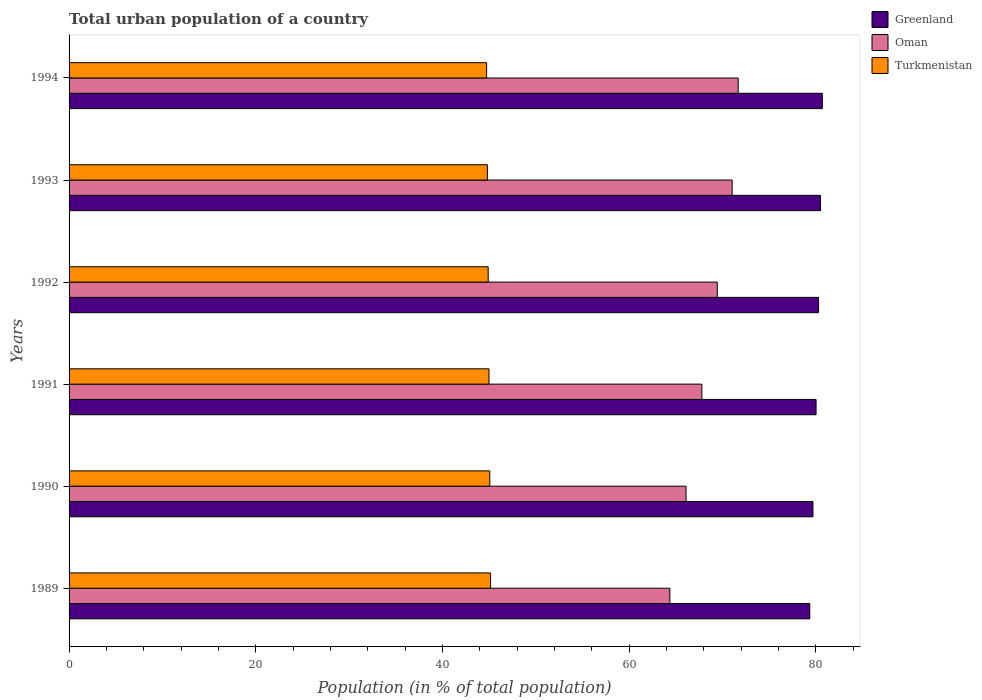How many different coloured bars are there?
Provide a short and direct response. 3. Are the number of bars per tick equal to the number of legend labels?
Provide a short and direct response. Yes. Are the number of bars on each tick of the Y-axis equal?
Make the answer very short. Yes. How many bars are there on the 3rd tick from the top?
Your answer should be very brief. 3. What is the label of the 5th group of bars from the top?
Keep it short and to the point. 1990. In how many cases, is the number of bars for a given year not equal to the number of legend labels?
Keep it short and to the point. 0. What is the urban population in Greenland in 1989?
Make the answer very short. 79.36. Across all years, what is the maximum urban population in Oman?
Keep it short and to the point. 71.69. Across all years, what is the minimum urban population in Oman?
Give a very brief answer. 64.37. What is the total urban population in Oman in the graph?
Give a very brief answer. 410.44. What is the difference between the urban population in Oman in 1990 and that in 1991?
Your answer should be very brief. -1.69. What is the difference between the urban population in Greenland in 1992 and the urban population in Oman in 1991?
Provide a succinct answer. 12.5. What is the average urban population in Greenland per year?
Your response must be concise. 80.1. In the year 1990, what is the difference between the urban population in Oman and urban population in Turkmenistan?
Your response must be concise. 21.03. In how many years, is the urban population in Greenland greater than 68 %?
Provide a succinct answer. 6. What is the ratio of the urban population in Oman in 1989 to that in 1993?
Offer a terse response. 0.91. Is the urban population in Oman in 1989 less than that in 1991?
Provide a succinct answer. Yes. Is the difference between the urban population in Oman in 1993 and 1994 greater than the difference between the urban population in Turkmenistan in 1993 and 1994?
Offer a terse response. No. What is the difference between the highest and the second highest urban population in Turkmenistan?
Your response must be concise. 0.08. What is the difference between the highest and the lowest urban population in Greenland?
Your answer should be compact. 1.34. What does the 3rd bar from the top in 1992 represents?
Ensure brevity in your answer.  Greenland. What does the 1st bar from the bottom in 1992 represents?
Your response must be concise. Greenland. Are all the bars in the graph horizontal?
Offer a terse response. Yes. What is the difference between two consecutive major ticks on the X-axis?
Offer a very short reply. 20. Are the values on the major ticks of X-axis written in scientific E-notation?
Offer a very short reply. No. Does the graph contain any zero values?
Your answer should be compact. No. Where does the legend appear in the graph?
Your response must be concise. Top right. How many legend labels are there?
Provide a short and direct response. 3. What is the title of the graph?
Provide a short and direct response. Total urban population of a country. What is the label or title of the X-axis?
Your response must be concise. Population (in % of total population). What is the label or title of the Y-axis?
Your response must be concise. Years. What is the Population (in % of total population) of Greenland in 1989?
Your response must be concise. 79.36. What is the Population (in % of total population) of Oman in 1989?
Keep it short and to the point. 64.37. What is the Population (in % of total population) of Turkmenistan in 1989?
Offer a very short reply. 45.16. What is the Population (in % of total population) in Greenland in 1990?
Your response must be concise. 79.7. What is the Population (in % of total population) of Oman in 1990?
Offer a terse response. 66.1. What is the Population (in % of total population) in Turkmenistan in 1990?
Make the answer very short. 45.08. What is the Population (in % of total population) in Greenland in 1991?
Make the answer very short. 80.03. What is the Population (in % of total population) in Oman in 1991?
Ensure brevity in your answer.  67.8. What is the Population (in % of total population) of Turkmenistan in 1991?
Give a very brief answer. 44.99. What is the Population (in % of total population) in Greenland in 1992?
Provide a short and direct response. 80.3. What is the Population (in % of total population) of Oman in 1992?
Give a very brief answer. 69.45. What is the Population (in % of total population) of Turkmenistan in 1992?
Offer a very short reply. 44.9. What is the Population (in % of total population) of Greenland in 1993?
Your answer should be compact. 80.5. What is the Population (in % of total population) in Oman in 1993?
Provide a succinct answer. 71.04. What is the Population (in % of total population) of Turkmenistan in 1993?
Give a very brief answer. 44.82. What is the Population (in % of total population) in Greenland in 1994?
Offer a terse response. 80.7. What is the Population (in % of total population) in Oman in 1994?
Your answer should be very brief. 71.69. What is the Population (in % of total population) in Turkmenistan in 1994?
Make the answer very short. 44.73. Across all years, what is the maximum Population (in % of total population) in Greenland?
Give a very brief answer. 80.7. Across all years, what is the maximum Population (in % of total population) of Oman?
Make the answer very short. 71.69. Across all years, what is the maximum Population (in % of total population) of Turkmenistan?
Make the answer very short. 45.16. Across all years, what is the minimum Population (in % of total population) in Greenland?
Make the answer very short. 79.36. Across all years, what is the minimum Population (in % of total population) of Oman?
Your response must be concise. 64.37. Across all years, what is the minimum Population (in % of total population) in Turkmenistan?
Your response must be concise. 44.73. What is the total Population (in % of total population) of Greenland in the graph?
Ensure brevity in your answer.  480.6. What is the total Population (in % of total population) of Oman in the graph?
Your answer should be very brief. 410.44. What is the total Population (in % of total population) of Turkmenistan in the graph?
Your answer should be compact. 269.68. What is the difference between the Population (in % of total population) in Greenland in 1989 and that in 1990?
Your response must be concise. -0.34. What is the difference between the Population (in % of total population) of Oman in 1989 and that in 1990?
Your answer should be compact. -1.74. What is the difference between the Population (in % of total population) in Turkmenistan in 1989 and that in 1990?
Provide a succinct answer. 0.09. What is the difference between the Population (in % of total population) in Greenland in 1989 and that in 1991?
Your response must be concise. -0.67. What is the difference between the Population (in % of total population) in Oman in 1989 and that in 1991?
Offer a very short reply. -3.43. What is the difference between the Population (in % of total population) of Turkmenistan in 1989 and that in 1991?
Offer a very short reply. 0.17. What is the difference between the Population (in % of total population) of Greenland in 1989 and that in 1992?
Offer a terse response. -0.94. What is the difference between the Population (in % of total population) in Oman in 1989 and that in 1992?
Your answer should be compact. -5.08. What is the difference between the Population (in % of total population) in Turkmenistan in 1989 and that in 1992?
Make the answer very short. 0.26. What is the difference between the Population (in % of total population) in Greenland in 1989 and that in 1993?
Make the answer very short. -1.14. What is the difference between the Population (in % of total population) in Oman in 1989 and that in 1993?
Keep it short and to the point. -6.68. What is the difference between the Population (in % of total population) in Turkmenistan in 1989 and that in 1993?
Make the answer very short. 0.34. What is the difference between the Population (in % of total population) of Greenland in 1989 and that in 1994?
Your answer should be very brief. -1.34. What is the difference between the Population (in % of total population) in Oman in 1989 and that in 1994?
Provide a succinct answer. -7.32. What is the difference between the Population (in % of total population) in Turkmenistan in 1989 and that in 1994?
Ensure brevity in your answer.  0.43. What is the difference between the Population (in % of total population) of Greenland in 1990 and that in 1991?
Your answer should be very brief. -0.34. What is the difference between the Population (in % of total population) of Oman in 1990 and that in 1991?
Your answer should be very brief. -1.69. What is the difference between the Population (in % of total population) in Turkmenistan in 1990 and that in 1991?
Your response must be concise. 0.09. What is the difference between the Population (in % of total population) in Greenland in 1990 and that in 1992?
Your answer should be very brief. -0.6. What is the difference between the Population (in % of total population) in Oman in 1990 and that in 1992?
Your answer should be compact. -3.35. What is the difference between the Population (in % of total population) in Turkmenistan in 1990 and that in 1992?
Provide a succinct answer. 0.17. What is the difference between the Population (in % of total population) in Greenland in 1990 and that in 1993?
Your response must be concise. -0.81. What is the difference between the Population (in % of total population) of Oman in 1990 and that in 1993?
Provide a short and direct response. -4.94. What is the difference between the Population (in % of total population) in Turkmenistan in 1990 and that in 1993?
Provide a succinct answer. 0.26. What is the difference between the Population (in % of total population) of Greenland in 1990 and that in 1994?
Your answer should be compact. -1. What is the difference between the Population (in % of total population) of Oman in 1990 and that in 1994?
Keep it short and to the point. -5.59. What is the difference between the Population (in % of total population) in Turkmenistan in 1990 and that in 1994?
Offer a terse response. 0.34. What is the difference between the Population (in % of total population) in Greenland in 1991 and that in 1992?
Provide a succinct answer. -0.27. What is the difference between the Population (in % of total population) in Oman in 1991 and that in 1992?
Ensure brevity in your answer.  -1.65. What is the difference between the Population (in % of total population) of Turkmenistan in 1991 and that in 1992?
Provide a short and direct response. 0.09. What is the difference between the Population (in % of total population) of Greenland in 1991 and that in 1993?
Your answer should be very brief. -0.47. What is the difference between the Population (in % of total population) of Oman in 1991 and that in 1993?
Your answer should be compact. -3.25. What is the difference between the Population (in % of total population) of Turkmenistan in 1991 and that in 1993?
Offer a very short reply. 0.17. What is the difference between the Population (in % of total population) in Greenland in 1991 and that in 1994?
Give a very brief answer. -0.67. What is the difference between the Population (in % of total population) of Oman in 1991 and that in 1994?
Make the answer very short. -3.89. What is the difference between the Population (in % of total population) of Turkmenistan in 1991 and that in 1994?
Give a very brief answer. 0.26. What is the difference between the Population (in % of total population) of Greenland in 1992 and that in 1993?
Your response must be concise. -0.2. What is the difference between the Population (in % of total population) in Oman in 1992 and that in 1993?
Provide a short and direct response. -1.6. What is the difference between the Population (in % of total population) of Turkmenistan in 1992 and that in 1993?
Give a very brief answer. 0.09. What is the difference between the Population (in % of total population) in Greenland in 1992 and that in 1994?
Keep it short and to the point. -0.4. What is the difference between the Population (in % of total population) of Oman in 1992 and that in 1994?
Your response must be concise. -2.24. What is the difference between the Population (in % of total population) in Turkmenistan in 1992 and that in 1994?
Make the answer very short. 0.17. What is the difference between the Population (in % of total population) of Oman in 1993 and that in 1994?
Your answer should be very brief. -0.64. What is the difference between the Population (in % of total population) of Turkmenistan in 1993 and that in 1994?
Provide a succinct answer. 0.09. What is the difference between the Population (in % of total population) of Greenland in 1989 and the Population (in % of total population) of Oman in 1990?
Offer a very short reply. 13.26. What is the difference between the Population (in % of total population) in Greenland in 1989 and the Population (in % of total population) in Turkmenistan in 1990?
Ensure brevity in your answer.  34.28. What is the difference between the Population (in % of total population) of Oman in 1989 and the Population (in % of total population) of Turkmenistan in 1990?
Your response must be concise. 19.29. What is the difference between the Population (in % of total population) of Greenland in 1989 and the Population (in % of total population) of Oman in 1991?
Give a very brief answer. 11.56. What is the difference between the Population (in % of total population) of Greenland in 1989 and the Population (in % of total population) of Turkmenistan in 1991?
Make the answer very short. 34.37. What is the difference between the Population (in % of total population) in Oman in 1989 and the Population (in % of total population) in Turkmenistan in 1991?
Your answer should be very brief. 19.38. What is the difference between the Population (in % of total population) of Greenland in 1989 and the Population (in % of total population) of Oman in 1992?
Provide a short and direct response. 9.91. What is the difference between the Population (in % of total population) of Greenland in 1989 and the Population (in % of total population) of Turkmenistan in 1992?
Your answer should be compact. 34.45. What is the difference between the Population (in % of total population) in Oman in 1989 and the Population (in % of total population) in Turkmenistan in 1992?
Give a very brief answer. 19.46. What is the difference between the Population (in % of total population) of Greenland in 1989 and the Population (in % of total population) of Oman in 1993?
Provide a short and direct response. 8.31. What is the difference between the Population (in % of total population) of Greenland in 1989 and the Population (in % of total population) of Turkmenistan in 1993?
Your answer should be very brief. 34.54. What is the difference between the Population (in % of total population) of Oman in 1989 and the Population (in % of total population) of Turkmenistan in 1993?
Offer a terse response. 19.55. What is the difference between the Population (in % of total population) of Greenland in 1989 and the Population (in % of total population) of Oman in 1994?
Provide a succinct answer. 7.67. What is the difference between the Population (in % of total population) in Greenland in 1989 and the Population (in % of total population) in Turkmenistan in 1994?
Your answer should be very brief. 34.62. What is the difference between the Population (in % of total population) in Oman in 1989 and the Population (in % of total population) in Turkmenistan in 1994?
Offer a very short reply. 19.63. What is the difference between the Population (in % of total population) of Greenland in 1990 and the Population (in % of total population) of Oman in 1991?
Give a very brief answer. 11.9. What is the difference between the Population (in % of total population) of Greenland in 1990 and the Population (in % of total population) of Turkmenistan in 1991?
Give a very brief answer. 34.71. What is the difference between the Population (in % of total population) in Oman in 1990 and the Population (in % of total population) in Turkmenistan in 1991?
Make the answer very short. 21.11. What is the difference between the Population (in % of total population) of Greenland in 1990 and the Population (in % of total population) of Oman in 1992?
Give a very brief answer. 10.25. What is the difference between the Population (in % of total population) in Greenland in 1990 and the Population (in % of total population) in Turkmenistan in 1992?
Provide a short and direct response. 34.79. What is the difference between the Population (in % of total population) in Oman in 1990 and the Population (in % of total population) in Turkmenistan in 1992?
Provide a short and direct response. 21.2. What is the difference between the Population (in % of total population) of Greenland in 1990 and the Population (in % of total population) of Oman in 1993?
Provide a short and direct response. 8.65. What is the difference between the Population (in % of total population) in Greenland in 1990 and the Population (in % of total population) in Turkmenistan in 1993?
Provide a short and direct response. 34.88. What is the difference between the Population (in % of total population) in Oman in 1990 and the Population (in % of total population) in Turkmenistan in 1993?
Your response must be concise. 21.28. What is the difference between the Population (in % of total population) in Greenland in 1990 and the Population (in % of total population) in Oman in 1994?
Give a very brief answer. 8.01. What is the difference between the Population (in % of total population) in Greenland in 1990 and the Population (in % of total population) in Turkmenistan in 1994?
Offer a terse response. 34.96. What is the difference between the Population (in % of total population) of Oman in 1990 and the Population (in % of total population) of Turkmenistan in 1994?
Ensure brevity in your answer.  21.37. What is the difference between the Population (in % of total population) of Greenland in 1991 and the Population (in % of total population) of Oman in 1992?
Your response must be concise. 10.59. What is the difference between the Population (in % of total population) in Greenland in 1991 and the Population (in % of total population) in Turkmenistan in 1992?
Your answer should be very brief. 35.13. What is the difference between the Population (in % of total population) in Oman in 1991 and the Population (in % of total population) in Turkmenistan in 1992?
Make the answer very short. 22.89. What is the difference between the Population (in % of total population) of Greenland in 1991 and the Population (in % of total population) of Oman in 1993?
Your answer should be very brief. 8.99. What is the difference between the Population (in % of total population) of Greenland in 1991 and the Population (in % of total population) of Turkmenistan in 1993?
Your answer should be compact. 35.21. What is the difference between the Population (in % of total population) of Oman in 1991 and the Population (in % of total population) of Turkmenistan in 1993?
Ensure brevity in your answer.  22.98. What is the difference between the Population (in % of total population) in Greenland in 1991 and the Population (in % of total population) in Oman in 1994?
Make the answer very short. 8.35. What is the difference between the Population (in % of total population) of Greenland in 1991 and the Population (in % of total population) of Turkmenistan in 1994?
Ensure brevity in your answer.  35.3. What is the difference between the Population (in % of total population) in Oman in 1991 and the Population (in % of total population) in Turkmenistan in 1994?
Provide a short and direct response. 23.06. What is the difference between the Population (in % of total population) of Greenland in 1992 and the Population (in % of total population) of Oman in 1993?
Provide a succinct answer. 9.26. What is the difference between the Population (in % of total population) in Greenland in 1992 and the Population (in % of total population) in Turkmenistan in 1993?
Offer a very short reply. 35.48. What is the difference between the Population (in % of total population) of Oman in 1992 and the Population (in % of total population) of Turkmenistan in 1993?
Give a very brief answer. 24.63. What is the difference between the Population (in % of total population) in Greenland in 1992 and the Population (in % of total population) in Oman in 1994?
Offer a very short reply. 8.61. What is the difference between the Population (in % of total population) in Greenland in 1992 and the Population (in % of total population) in Turkmenistan in 1994?
Your answer should be compact. 35.57. What is the difference between the Population (in % of total population) in Oman in 1992 and the Population (in % of total population) in Turkmenistan in 1994?
Make the answer very short. 24.71. What is the difference between the Population (in % of total population) of Greenland in 1993 and the Population (in % of total population) of Oman in 1994?
Give a very brief answer. 8.81. What is the difference between the Population (in % of total population) in Greenland in 1993 and the Population (in % of total population) in Turkmenistan in 1994?
Provide a succinct answer. 35.77. What is the difference between the Population (in % of total population) of Oman in 1993 and the Population (in % of total population) of Turkmenistan in 1994?
Provide a succinct answer. 26.31. What is the average Population (in % of total population) in Greenland per year?
Your answer should be very brief. 80.1. What is the average Population (in % of total population) of Oman per year?
Make the answer very short. 68.41. What is the average Population (in % of total population) of Turkmenistan per year?
Offer a very short reply. 44.95. In the year 1989, what is the difference between the Population (in % of total population) of Greenland and Population (in % of total population) of Oman?
Provide a succinct answer. 14.99. In the year 1989, what is the difference between the Population (in % of total population) in Greenland and Population (in % of total population) in Turkmenistan?
Ensure brevity in your answer.  34.2. In the year 1989, what is the difference between the Population (in % of total population) of Oman and Population (in % of total population) of Turkmenistan?
Ensure brevity in your answer.  19.21. In the year 1990, what is the difference between the Population (in % of total population) of Greenland and Population (in % of total population) of Oman?
Offer a terse response. 13.6. In the year 1990, what is the difference between the Population (in % of total population) in Greenland and Population (in % of total population) in Turkmenistan?
Provide a short and direct response. 34.62. In the year 1990, what is the difference between the Population (in % of total population) of Oman and Population (in % of total population) of Turkmenistan?
Your response must be concise. 21.03. In the year 1991, what is the difference between the Population (in % of total population) in Greenland and Population (in % of total population) in Oman?
Keep it short and to the point. 12.24. In the year 1991, what is the difference between the Population (in % of total population) of Greenland and Population (in % of total population) of Turkmenistan?
Make the answer very short. 35.04. In the year 1991, what is the difference between the Population (in % of total population) of Oman and Population (in % of total population) of Turkmenistan?
Offer a terse response. 22.81. In the year 1992, what is the difference between the Population (in % of total population) in Greenland and Population (in % of total population) in Oman?
Make the answer very short. 10.85. In the year 1992, what is the difference between the Population (in % of total population) of Greenland and Population (in % of total population) of Turkmenistan?
Your answer should be very brief. 35.4. In the year 1992, what is the difference between the Population (in % of total population) of Oman and Population (in % of total population) of Turkmenistan?
Ensure brevity in your answer.  24.54. In the year 1993, what is the difference between the Population (in % of total population) in Greenland and Population (in % of total population) in Oman?
Your response must be concise. 9.46. In the year 1993, what is the difference between the Population (in % of total population) of Greenland and Population (in % of total population) of Turkmenistan?
Offer a terse response. 35.68. In the year 1993, what is the difference between the Population (in % of total population) in Oman and Population (in % of total population) in Turkmenistan?
Keep it short and to the point. 26.23. In the year 1994, what is the difference between the Population (in % of total population) of Greenland and Population (in % of total population) of Oman?
Your answer should be very brief. 9.02. In the year 1994, what is the difference between the Population (in % of total population) in Greenland and Population (in % of total population) in Turkmenistan?
Your response must be concise. 35.97. In the year 1994, what is the difference between the Population (in % of total population) in Oman and Population (in % of total population) in Turkmenistan?
Offer a very short reply. 26.95. What is the ratio of the Population (in % of total population) in Greenland in 1989 to that in 1990?
Your response must be concise. 1. What is the ratio of the Population (in % of total population) in Oman in 1989 to that in 1990?
Make the answer very short. 0.97. What is the ratio of the Population (in % of total population) in Greenland in 1989 to that in 1991?
Ensure brevity in your answer.  0.99. What is the ratio of the Population (in % of total population) in Oman in 1989 to that in 1991?
Provide a short and direct response. 0.95. What is the ratio of the Population (in % of total population) of Turkmenistan in 1989 to that in 1991?
Provide a short and direct response. 1. What is the ratio of the Population (in % of total population) in Greenland in 1989 to that in 1992?
Your answer should be very brief. 0.99. What is the ratio of the Population (in % of total population) in Oman in 1989 to that in 1992?
Make the answer very short. 0.93. What is the ratio of the Population (in % of total population) of Turkmenistan in 1989 to that in 1992?
Your answer should be very brief. 1.01. What is the ratio of the Population (in % of total population) of Greenland in 1989 to that in 1993?
Provide a short and direct response. 0.99. What is the ratio of the Population (in % of total population) in Oman in 1989 to that in 1993?
Your answer should be compact. 0.91. What is the ratio of the Population (in % of total population) in Turkmenistan in 1989 to that in 1993?
Provide a succinct answer. 1.01. What is the ratio of the Population (in % of total population) in Greenland in 1989 to that in 1994?
Your answer should be compact. 0.98. What is the ratio of the Population (in % of total population) in Oman in 1989 to that in 1994?
Offer a very short reply. 0.9. What is the ratio of the Population (in % of total population) of Turkmenistan in 1989 to that in 1994?
Give a very brief answer. 1.01. What is the ratio of the Population (in % of total population) of Turkmenistan in 1990 to that in 1991?
Your answer should be very brief. 1. What is the ratio of the Population (in % of total population) in Greenland in 1990 to that in 1992?
Provide a short and direct response. 0.99. What is the ratio of the Population (in % of total population) in Oman in 1990 to that in 1992?
Your response must be concise. 0.95. What is the ratio of the Population (in % of total population) of Greenland in 1990 to that in 1993?
Your response must be concise. 0.99. What is the ratio of the Population (in % of total population) of Oman in 1990 to that in 1993?
Provide a succinct answer. 0.93. What is the ratio of the Population (in % of total population) of Greenland in 1990 to that in 1994?
Provide a succinct answer. 0.99. What is the ratio of the Population (in % of total population) in Oman in 1990 to that in 1994?
Provide a succinct answer. 0.92. What is the ratio of the Population (in % of total population) in Turkmenistan in 1990 to that in 1994?
Your response must be concise. 1.01. What is the ratio of the Population (in % of total population) in Greenland in 1991 to that in 1992?
Keep it short and to the point. 1. What is the ratio of the Population (in % of total population) in Oman in 1991 to that in 1992?
Ensure brevity in your answer.  0.98. What is the ratio of the Population (in % of total population) in Oman in 1991 to that in 1993?
Your response must be concise. 0.95. What is the ratio of the Population (in % of total population) in Turkmenistan in 1991 to that in 1993?
Provide a succinct answer. 1. What is the ratio of the Population (in % of total population) in Greenland in 1991 to that in 1994?
Ensure brevity in your answer.  0.99. What is the ratio of the Population (in % of total population) in Oman in 1991 to that in 1994?
Give a very brief answer. 0.95. What is the ratio of the Population (in % of total population) of Greenland in 1992 to that in 1993?
Ensure brevity in your answer.  1. What is the ratio of the Population (in % of total population) in Oman in 1992 to that in 1993?
Make the answer very short. 0.98. What is the ratio of the Population (in % of total population) in Turkmenistan in 1992 to that in 1993?
Provide a succinct answer. 1. What is the ratio of the Population (in % of total population) of Greenland in 1992 to that in 1994?
Ensure brevity in your answer.  0.99. What is the ratio of the Population (in % of total population) of Oman in 1992 to that in 1994?
Make the answer very short. 0.97. What is the ratio of the Population (in % of total population) of Greenland in 1993 to that in 1994?
Make the answer very short. 1. What is the ratio of the Population (in % of total population) of Oman in 1993 to that in 1994?
Provide a succinct answer. 0.99. What is the difference between the highest and the second highest Population (in % of total population) of Greenland?
Your answer should be compact. 0.2. What is the difference between the highest and the second highest Population (in % of total population) of Oman?
Provide a short and direct response. 0.64. What is the difference between the highest and the second highest Population (in % of total population) in Turkmenistan?
Make the answer very short. 0.09. What is the difference between the highest and the lowest Population (in % of total population) of Greenland?
Give a very brief answer. 1.34. What is the difference between the highest and the lowest Population (in % of total population) of Oman?
Offer a terse response. 7.32. What is the difference between the highest and the lowest Population (in % of total population) of Turkmenistan?
Keep it short and to the point. 0.43. 